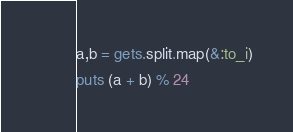Convert code to text. <code><loc_0><loc_0><loc_500><loc_500><_Ruby_>a,b = gets.split.map(&:to_i)
puts (a + b) % 24</code> 